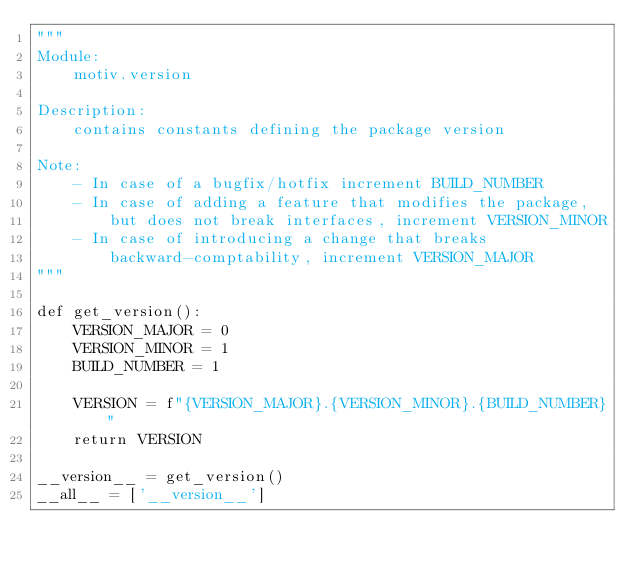Convert code to text. <code><loc_0><loc_0><loc_500><loc_500><_Python_>"""
Module:
    motiv.version

Description:
    contains constants defining the package version

Note:
    - In case of a bugfix/hotfix increment BUILD_NUMBER
    - In case of adding a feature that modifies the package,
        but does not break interfaces, increment VERSION_MINOR
    - In case of introducing a change that breaks
        backward-comptability, increment VERSION_MAJOR
"""

def get_version():
    VERSION_MAJOR = 0
    VERSION_MINOR = 1
    BUILD_NUMBER = 1

    VERSION = f"{VERSION_MAJOR}.{VERSION_MINOR}.{BUILD_NUMBER}"
    return VERSION

__version__ = get_version()
__all__ = ['__version__']
</code> 